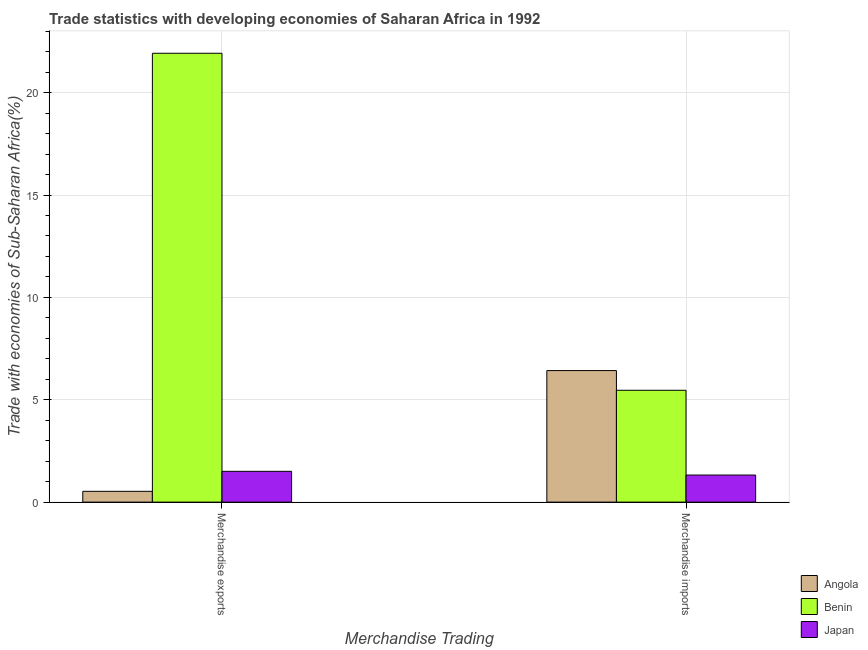Are the number of bars per tick equal to the number of legend labels?
Your answer should be very brief. Yes. Are the number of bars on each tick of the X-axis equal?
Offer a very short reply. Yes. What is the label of the 2nd group of bars from the left?
Offer a terse response. Merchandise imports. What is the merchandise exports in Benin?
Offer a very short reply. 21.92. Across all countries, what is the maximum merchandise imports?
Your answer should be very brief. 6.42. Across all countries, what is the minimum merchandise exports?
Provide a succinct answer. 0.53. In which country was the merchandise imports maximum?
Provide a succinct answer. Angola. In which country was the merchandise exports minimum?
Keep it short and to the point. Angola. What is the total merchandise exports in the graph?
Ensure brevity in your answer.  23.96. What is the difference between the merchandise imports in Japan and that in Benin?
Your answer should be compact. -4.14. What is the difference between the merchandise exports in Japan and the merchandise imports in Angola?
Your answer should be compact. -4.92. What is the average merchandise imports per country?
Keep it short and to the point. 4.4. What is the difference between the merchandise imports and merchandise exports in Benin?
Give a very brief answer. -16.46. What is the ratio of the merchandise exports in Angola to that in Benin?
Offer a very short reply. 0.02. Is the merchandise imports in Angola less than that in Japan?
Provide a short and direct response. No. What does the 1st bar from the left in Merchandise exports represents?
Ensure brevity in your answer.  Angola. Are the values on the major ticks of Y-axis written in scientific E-notation?
Give a very brief answer. No. Does the graph contain any zero values?
Ensure brevity in your answer.  No. How many legend labels are there?
Offer a terse response. 3. What is the title of the graph?
Offer a very short reply. Trade statistics with developing economies of Saharan Africa in 1992. What is the label or title of the X-axis?
Provide a short and direct response. Merchandise Trading. What is the label or title of the Y-axis?
Provide a succinct answer. Trade with economies of Sub-Saharan Africa(%). What is the Trade with economies of Sub-Saharan Africa(%) of Angola in Merchandise exports?
Give a very brief answer. 0.53. What is the Trade with economies of Sub-Saharan Africa(%) in Benin in Merchandise exports?
Offer a terse response. 21.92. What is the Trade with economies of Sub-Saharan Africa(%) in Japan in Merchandise exports?
Provide a short and direct response. 1.5. What is the Trade with economies of Sub-Saharan Africa(%) of Angola in Merchandise imports?
Keep it short and to the point. 6.42. What is the Trade with economies of Sub-Saharan Africa(%) in Benin in Merchandise imports?
Keep it short and to the point. 5.46. What is the Trade with economies of Sub-Saharan Africa(%) in Japan in Merchandise imports?
Make the answer very short. 1.32. Across all Merchandise Trading, what is the maximum Trade with economies of Sub-Saharan Africa(%) of Angola?
Ensure brevity in your answer.  6.42. Across all Merchandise Trading, what is the maximum Trade with economies of Sub-Saharan Africa(%) of Benin?
Your answer should be very brief. 21.92. Across all Merchandise Trading, what is the maximum Trade with economies of Sub-Saharan Africa(%) of Japan?
Provide a short and direct response. 1.5. Across all Merchandise Trading, what is the minimum Trade with economies of Sub-Saharan Africa(%) of Angola?
Your response must be concise. 0.53. Across all Merchandise Trading, what is the minimum Trade with economies of Sub-Saharan Africa(%) in Benin?
Make the answer very short. 5.46. Across all Merchandise Trading, what is the minimum Trade with economies of Sub-Saharan Africa(%) of Japan?
Your answer should be compact. 1.32. What is the total Trade with economies of Sub-Saharan Africa(%) of Angola in the graph?
Your response must be concise. 6.95. What is the total Trade with economies of Sub-Saharan Africa(%) in Benin in the graph?
Your answer should be very brief. 27.39. What is the total Trade with economies of Sub-Saharan Africa(%) in Japan in the graph?
Provide a short and direct response. 2.83. What is the difference between the Trade with economies of Sub-Saharan Africa(%) in Angola in Merchandise exports and that in Merchandise imports?
Make the answer very short. -5.9. What is the difference between the Trade with economies of Sub-Saharan Africa(%) in Benin in Merchandise exports and that in Merchandise imports?
Your answer should be very brief. 16.46. What is the difference between the Trade with economies of Sub-Saharan Africa(%) in Japan in Merchandise exports and that in Merchandise imports?
Give a very brief answer. 0.18. What is the difference between the Trade with economies of Sub-Saharan Africa(%) of Angola in Merchandise exports and the Trade with economies of Sub-Saharan Africa(%) of Benin in Merchandise imports?
Ensure brevity in your answer.  -4.94. What is the difference between the Trade with economies of Sub-Saharan Africa(%) of Angola in Merchandise exports and the Trade with economies of Sub-Saharan Africa(%) of Japan in Merchandise imports?
Your answer should be compact. -0.79. What is the difference between the Trade with economies of Sub-Saharan Africa(%) of Benin in Merchandise exports and the Trade with economies of Sub-Saharan Africa(%) of Japan in Merchandise imports?
Your answer should be compact. 20.6. What is the average Trade with economies of Sub-Saharan Africa(%) of Angola per Merchandise Trading?
Offer a terse response. 3.48. What is the average Trade with economies of Sub-Saharan Africa(%) of Benin per Merchandise Trading?
Provide a short and direct response. 13.69. What is the average Trade with economies of Sub-Saharan Africa(%) of Japan per Merchandise Trading?
Give a very brief answer. 1.41. What is the difference between the Trade with economies of Sub-Saharan Africa(%) in Angola and Trade with economies of Sub-Saharan Africa(%) in Benin in Merchandise exports?
Give a very brief answer. -21.4. What is the difference between the Trade with economies of Sub-Saharan Africa(%) of Angola and Trade with economies of Sub-Saharan Africa(%) of Japan in Merchandise exports?
Offer a very short reply. -0.98. What is the difference between the Trade with economies of Sub-Saharan Africa(%) of Benin and Trade with economies of Sub-Saharan Africa(%) of Japan in Merchandise exports?
Provide a succinct answer. 20.42. What is the difference between the Trade with economies of Sub-Saharan Africa(%) in Angola and Trade with economies of Sub-Saharan Africa(%) in Benin in Merchandise imports?
Ensure brevity in your answer.  0.96. What is the difference between the Trade with economies of Sub-Saharan Africa(%) in Angola and Trade with economies of Sub-Saharan Africa(%) in Japan in Merchandise imports?
Give a very brief answer. 5.1. What is the difference between the Trade with economies of Sub-Saharan Africa(%) in Benin and Trade with economies of Sub-Saharan Africa(%) in Japan in Merchandise imports?
Keep it short and to the point. 4.14. What is the ratio of the Trade with economies of Sub-Saharan Africa(%) of Angola in Merchandise exports to that in Merchandise imports?
Your answer should be compact. 0.08. What is the ratio of the Trade with economies of Sub-Saharan Africa(%) in Benin in Merchandise exports to that in Merchandise imports?
Your answer should be compact. 4.01. What is the ratio of the Trade with economies of Sub-Saharan Africa(%) of Japan in Merchandise exports to that in Merchandise imports?
Offer a very short reply. 1.14. What is the difference between the highest and the second highest Trade with economies of Sub-Saharan Africa(%) in Angola?
Ensure brevity in your answer.  5.9. What is the difference between the highest and the second highest Trade with economies of Sub-Saharan Africa(%) in Benin?
Make the answer very short. 16.46. What is the difference between the highest and the second highest Trade with economies of Sub-Saharan Africa(%) of Japan?
Ensure brevity in your answer.  0.18. What is the difference between the highest and the lowest Trade with economies of Sub-Saharan Africa(%) of Angola?
Your answer should be compact. 5.9. What is the difference between the highest and the lowest Trade with economies of Sub-Saharan Africa(%) in Benin?
Provide a short and direct response. 16.46. What is the difference between the highest and the lowest Trade with economies of Sub-Saharan Africa(%) of Japan?
Provide a short and direct response. 0.18. 